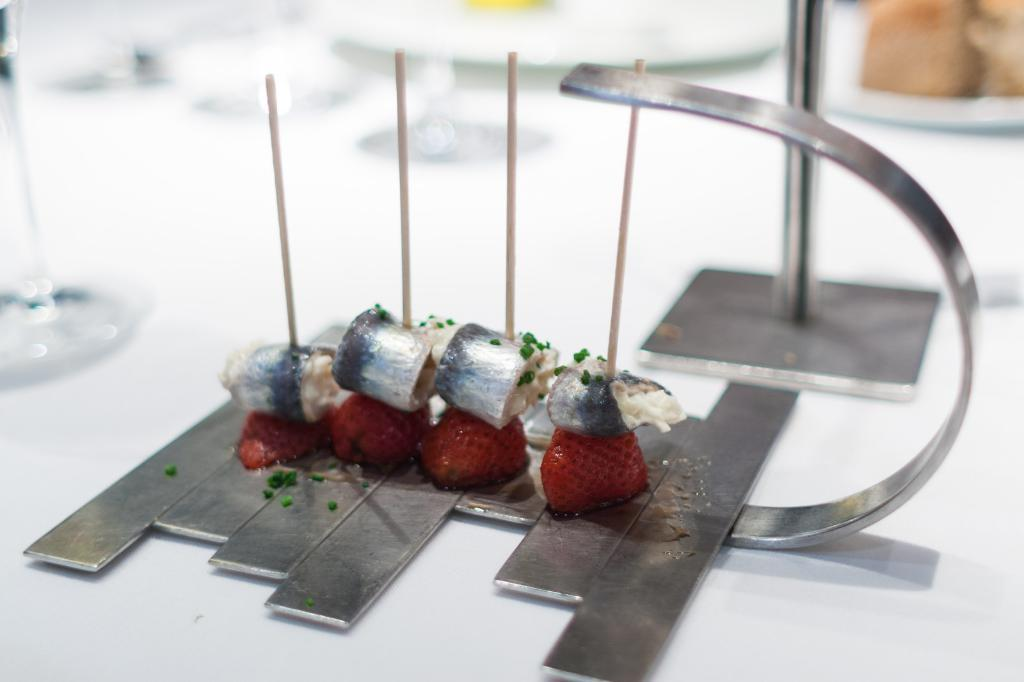What is the main subject of the image? There is a food item on a white table in the image. Can you describe any other objects on the table? There is a glass on the left side of the table. What else can be seen in the image, apart from the food item and glass? There are other food items visible at the back of the image. What type of fruit is being used to represent society in the image? There is no fruit or representation of society present in the image. Can you tell me what kind of pet is sitting next to the food item in the image? There is no pet visible in the image; it only features a food item, a glass, and other food items at the back. 